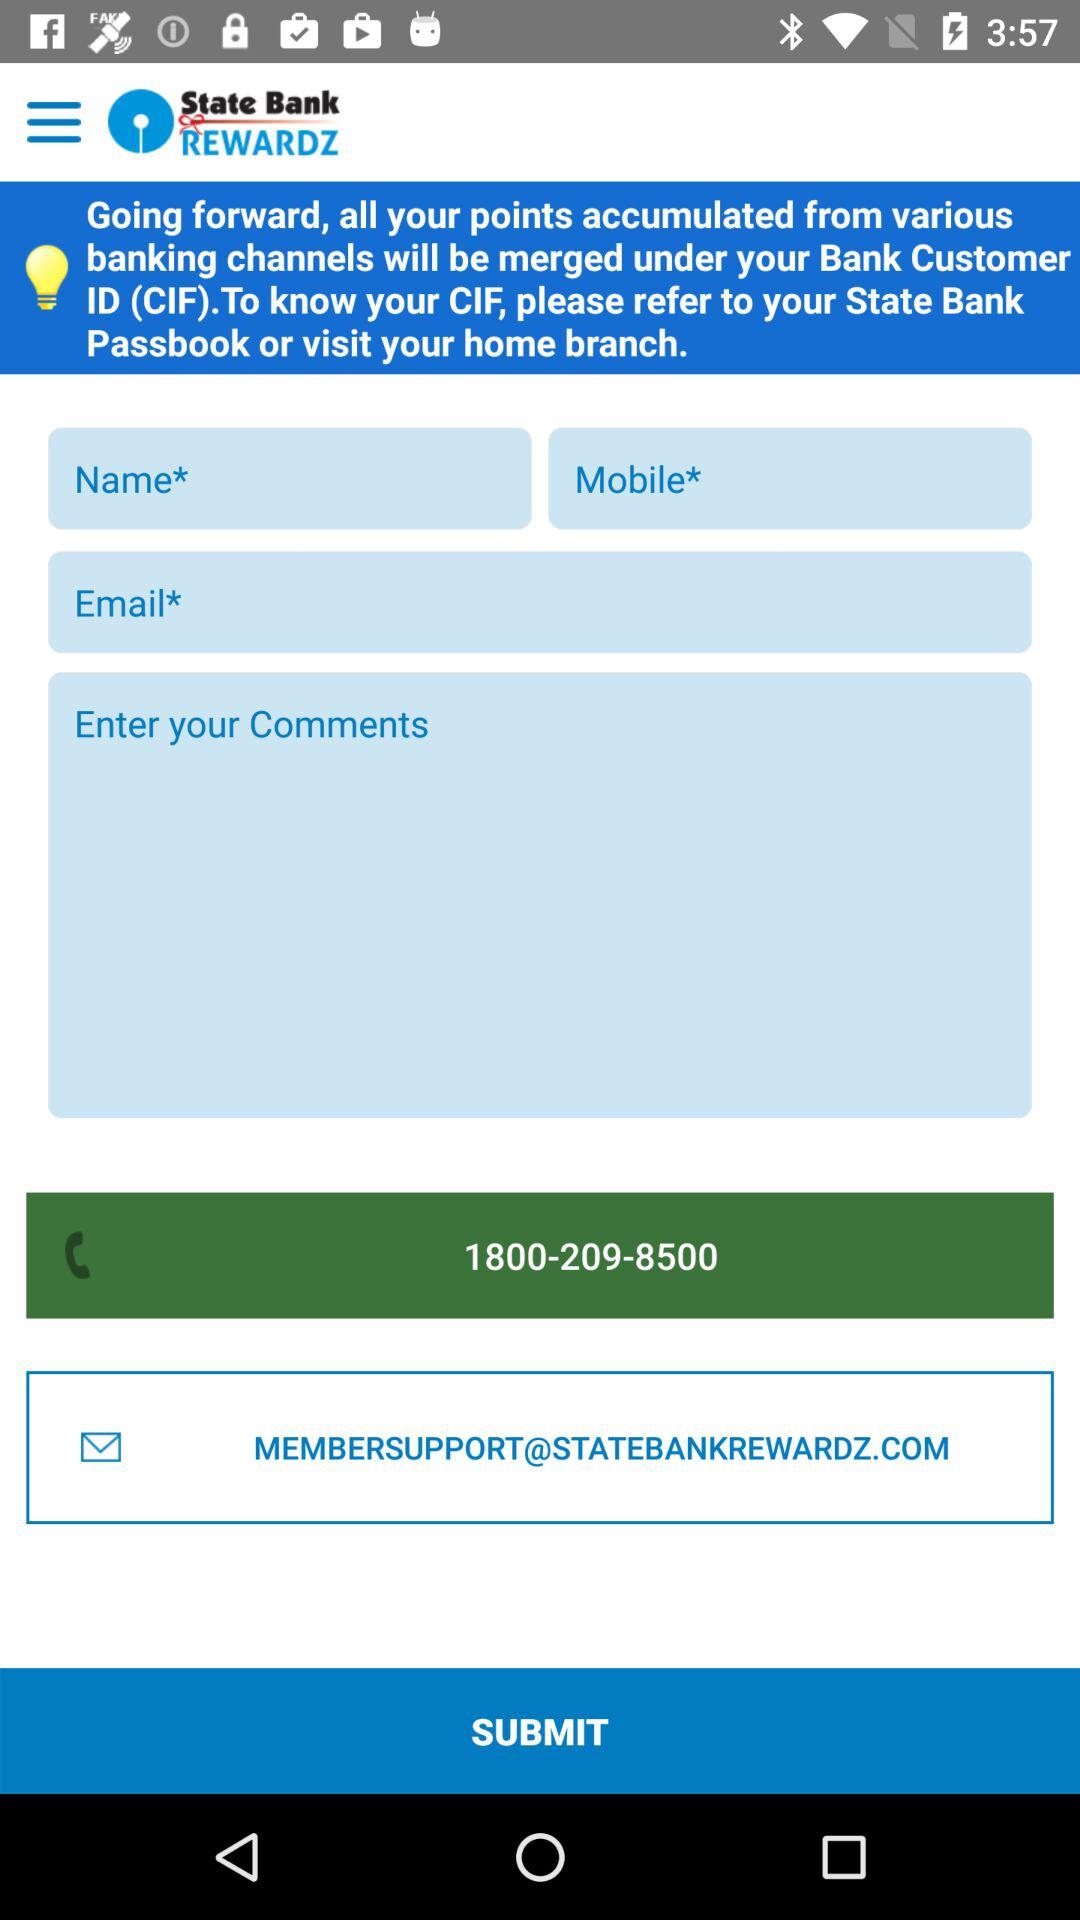What is the support email address? The support email address is MEMBERSUPPORT@STATEBANKREWARDZ.COM. 